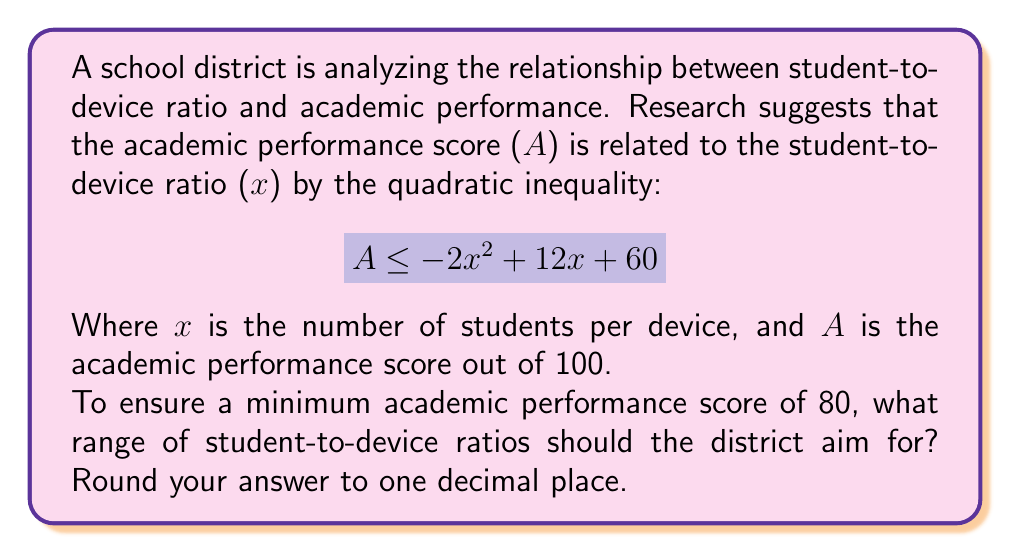Could you help me with this problem? To solve this problem, we need to follow these steps:

1) We want A to be at least 80, so we replace the inequality with:

   $$ 80 \leq -2x^2 + 12x + 60 $$

2) Rearrange the inequality:

   $$ 0 \leq -2x^2 + 12x - 20 $$

3) Multiply everything by -1, remembering to flip the inequality sign:

   $$ 0 \geq 2x^2 - 12x + 20 $$

4) This is a quadratic inequality. To solve it, we first find the roots of the quadratic equation:

   $$ 2x^2 - 12x + 20 = 0 $$

5) We can solve this using the quadratic formula: $x = \frac{-b \pm \sqrt{b^2 - 4ac}}{2a}$

   Where $a=2$, $b=-12$, and $c=20$

6) Plugging in these values:

   $$ x = \frac{12 \pm \sqrt{144 - 160}}{4} = \frac{12 \pm \sqrt{-16}}{4} = \frac{12 \pm 4i}{4} $$

7) Since we get complex roots, this means the parabola never crosses the x-axis. The inequality is satisfied when the parabola is below or equal to the x-axis.

8) To determine when this happens, we need to find the vertex of the parabola. The x-coordinate of the vertex is given by $x = -\frac{b}{2a}$:

   $$ x = -\frac{-12}{2(2)} = 3 $$

9) Since the parabola opens upward (the coefficient of $x^2$ is positive) and never crosses the x-axis, the inequality is satisfied for all x-values less than or equal to 3.

Therefore, the range of student-to-device ratios that satisfy the inequality is $x \leq 3$.
Answer: $x \leq 3.0$ 